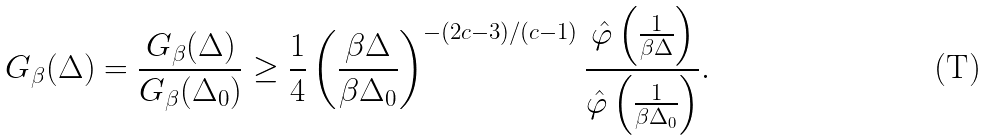Convert formula to latex. <formula><loc_0><loc_0><loc_500><loc_500>G _ { \beta } ( \Delta ) = \frac { G _ { \beta } ( \Delta ) } { G _ { \beta } ( \Delta _ { 0 } ) } \geq \frac { 1 } { 4 } \left ( \frac { \beta \Delta } { \beta \Delta _ { 0 } } \right ) ^ { - ( 2 c - 3 ) / ( c - 1 ) } \frac { \hat { \varphi } \left ( \frac { 1 } { \beta \Delta } \right ) } { \hat { \varphi } \left ( \frac { 1 } { \beta \Delta _ { 0 } } \right ) } .</formula> 